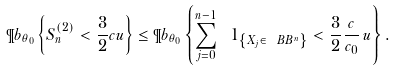Convert formula to latex. <formula><loc_0><loc_0><loc_500><loc_500>\P b _ { \theta _ { 0 } } \left \{ S _ { n } ^ { \left ( 2 \right ) } < \frac { 3 } { 2 } c u \right \} \leq \P b _ { \theta _ { 0 } } \left \{ \sum _ { j = 0 } ^ { n - 1 } \ 1 _ { \left \{ X _ { j } \in \ B B ^ { n } \right \} } < \frac { 3 } { 2 } \frac { c } { c _ { 0 } } \, u \right \} .</formula> 